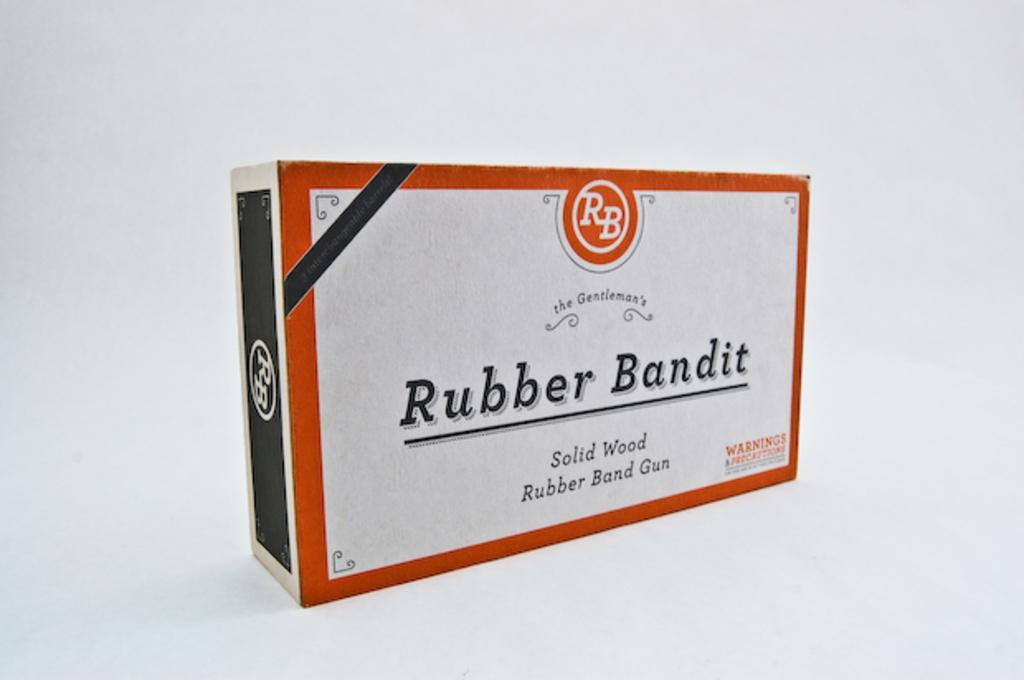<image>
Relay a brief, clear account of the picture shown. A box for a Rubber Bandit brand rubber band gun. 